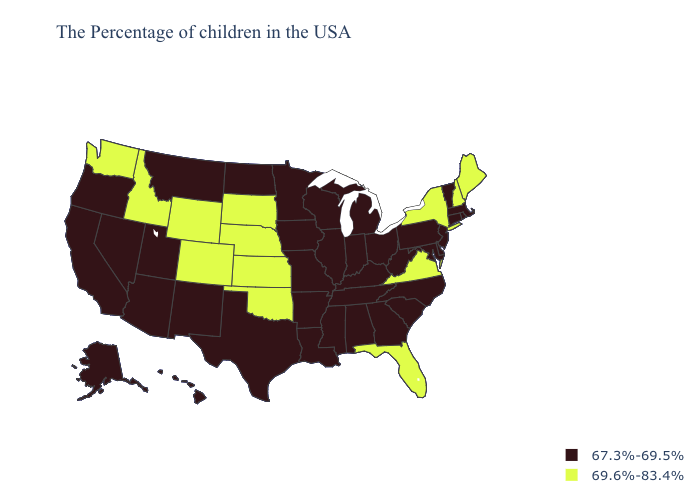How many symbols are there in the legend?
Concise answer only. 2. Which states have the lowest value in the USA?
Answer briefly. Massachusetts, Rhode Island, Vermont, Connecticut, New Jersey, Delaware, Maryland, Pennsylvania, North Carolina, South Carolina, West Virginia, Ohio, Georgia, Michigan, Kentucky, Indiana, Alabama, Tennessee, Wisconsin, Illinois, Mississippi, Louisiana, Missouri, Arkansas, Minnesota, Iowa, Texas, North Dakota, New Mexico, Utah, Montana, Arizona, Nevada, California, Oregon, Alaska, Hawaii. Does New Jersey have a lower value than Alabama?
Give a very brief answer. No. Does Utah have a higher value than Minnesota?
Keep it brief. No. What is the lowest value in states that border Oklahoma?
Give a very brief answer. 67.3%-69.5%. What is the lowest value in the USA?
Give a very brief answer. 67.3%-69.5%. How many symbols are there in the legend?
Write a very short answer. 2. Name the states that have a value in the range 69.6%-83.4%?
Write a very short answer. Maine, New Hampshire, New York, Virginia, Florida, Kansas, Nebraska, Oklahoma, South Dakota, Wyoming, Colorado, Idaho, Washington. Among the states that border Nevada , does Oregon have the lowest value?
Keep it brief. Yes. What is the value of South Dakota?
Be succinct. 69.6%-83.4%. Name the states that have a value in the range 69.6%-83.4%?
Give a very brief answer. Maine, New Hampshire, New York, Virginia, Florida, Kansas, Nebraska, Oklahoma, South Dakota, Wyoming, Colorado, Idaho, Washington. How many symbols are there in the legend?
Quick response, please. 2. Which states hav the highest value in the West?
Be succinct. Wyoming, Colorado, Idaho, Washington. Name the states that have a value in the range 69.6%-83.4%?
Quick response, please. Maine, New Hampshire, New York, Virginia, Florida, Kansas, Nebraska, Oklahoma, South Dakota, Wyoming, Colorado, Idaho, Washington. Name the states that have a value in the range 67.3%-69.5%?
Answer briefly. Massachusetts, Rhode Island, Vermont, Connecticut, New Jersey, Delaware, Maryland, Pennsylvania, North Carolina, South Carolina, West Virginia, Ohio, Georgia, Michigan, Kentucky, Indiana, Alabama, Tennessee, Wisconsin, Illinois, Mississippi, Louisiana, Missouri, Arkansas, Minnesota, Iowa, Texas, North Dakota, New Mexico, Utah, Montana, Arizona, Nevada, California, Oregon, Alaska, Hawaii. 